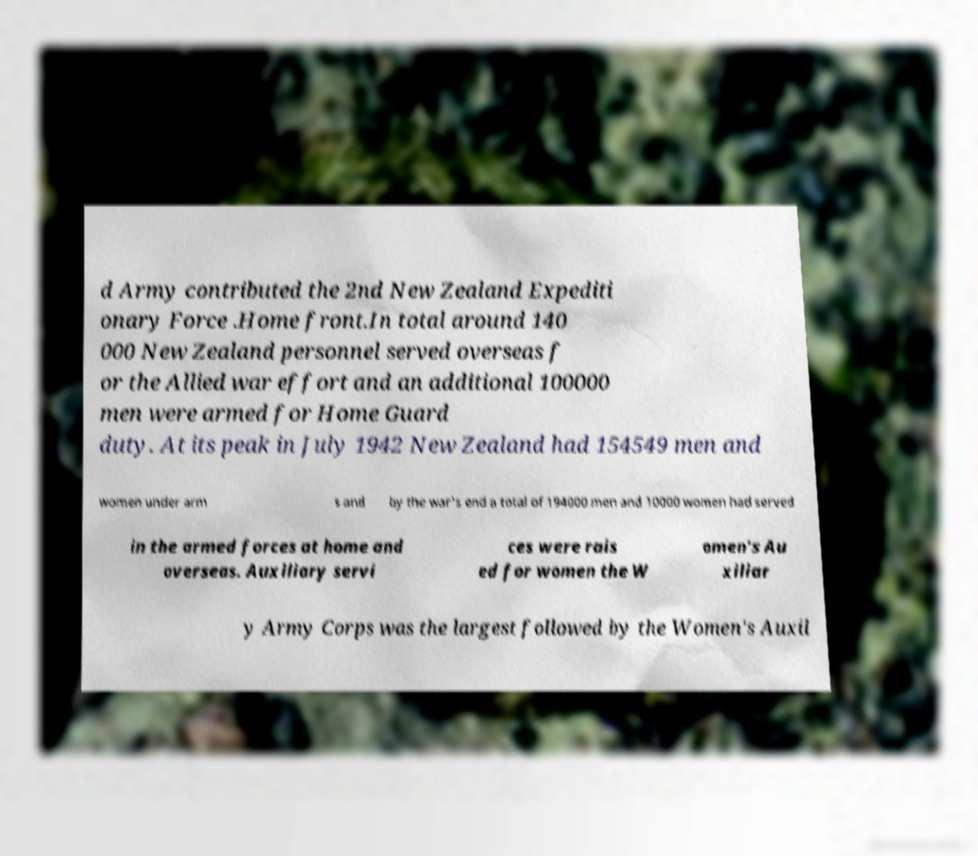Please identify and transcribe the text found in this image. d Army contributed the 2nd New Zealand Expediti onary Force .Home front.In total around 140 000 New Zealand personnel served overseas f or the Allied war effort and an additional 100000 men were armed for Home Guard duty. At its peak in July 1942 New Zealand had 154549 men and women under arm s and by the war's end a total of 194000 men and 10000 women had served in the armed forces at home and overseas. Auxiliary servi ces were rais ed for women the W omen's Au xiliar y Army Corps was the largest followed by the Women's Auxil 